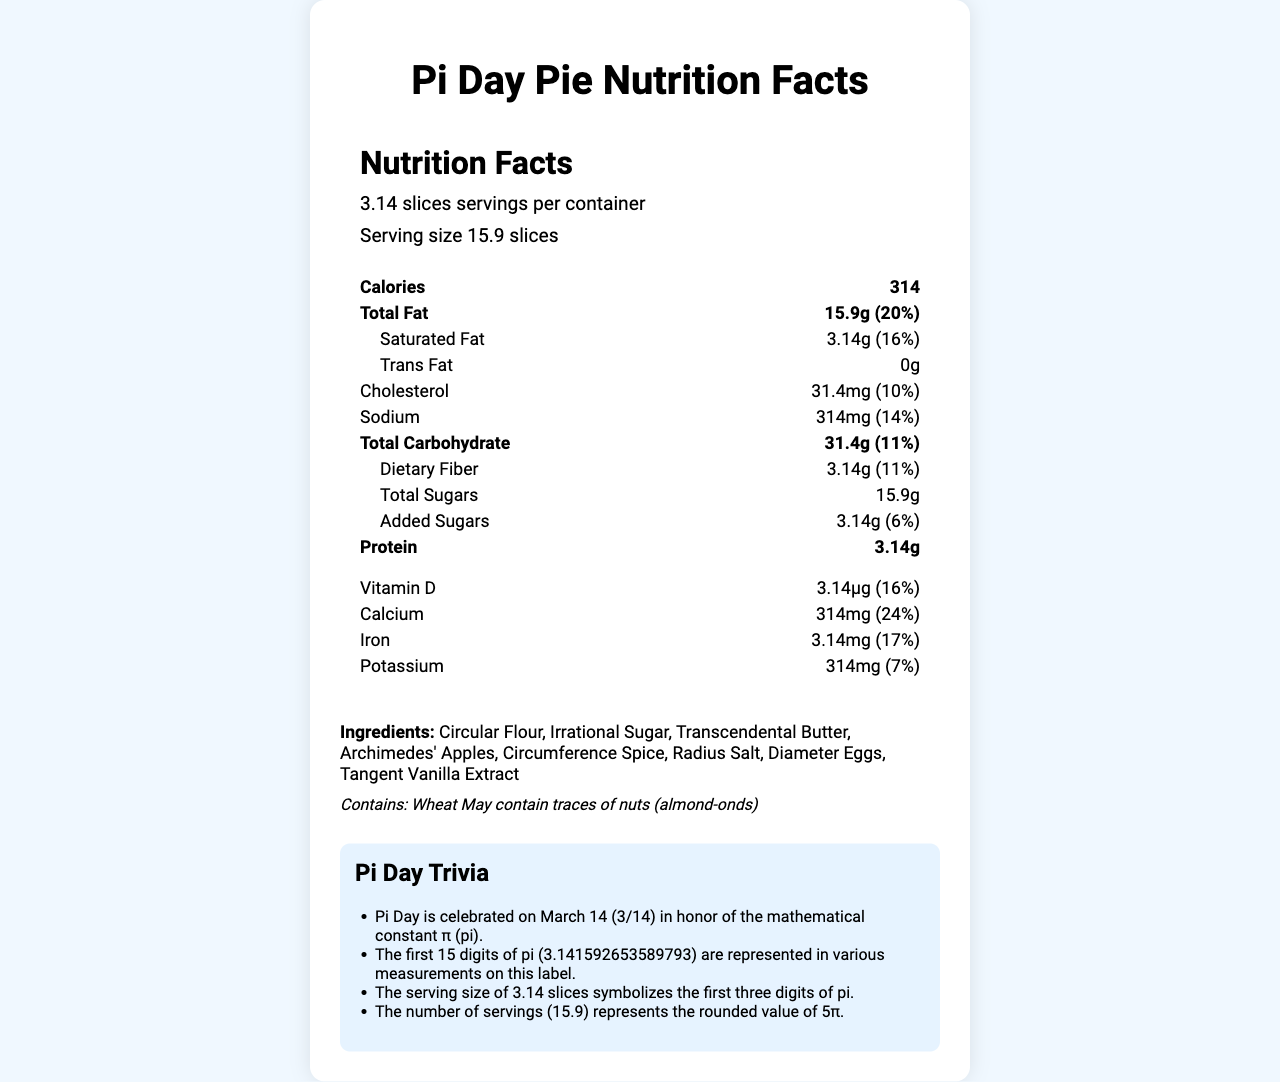what is the serving size for the Pi Day Pie? The serving size is clearly listed as "3.14 slices" in the document.
Answer: 3.14 slices how many calories are there per serving? The number of calories per serving is listed as "314" in the document.
Answer: 314 what percentage of the daily value is provided by the total fat in one serving? The daily value percentage for total fat is listed as "20%" for one serving.
Answer: 20% how much vitamin D is in a serving and what percentage of the daily value does this represent? There are 3.14 micrograms of vitamin D in a serving, which represents 16% of the daily value.
Answer: 3.14 micrograms, 16% what ingredients are present in the Pi Day Pie? The ingredients are listed under the ingredients section in the document.
Answer: Circular Flour, Irrational Sugar, Transcendental Butter, Archimedes' Apples, Circumference Spice, Radius Salt, Diameter Eggs, Tangent Vanilla Extract how much sodium is there per serving? Sodium content is listed as "314 milligrams" per serving.
Answer: 314 milligrams what is the significance of the serving size being 3.14 slices? A. It adheres to FDA guidelines B. It represents the first three digits of pi C. It is because the pie is very calorie-dense D. It was chosen randomly The serving size of 3.14 slices symbolizes the first three digits of pi as indicated in the trivia section.
Answer: B how many servings are there per container? A. 10 B. 12 C. 15.9 D. 20 The number of servings per container is listed as "15.9".
Answer: C is there any trans fat in the Pi Day Pie? The document lists the amount of trans fat as "0 grams".
Answer: No describe the main idea of the Pi Day Pie nutrition facts document. The document provides nutrition information for a pie themed around the mathematical constant pi, with serving sizes and nutritional values creatively aligning with pi’s digits. It includes calorie counts, fat content, vitamins, and minerals, along with ingredient and allergen info, and fun trivia about Pi.
Answer: The document displays the nutrition facts for a Pi Day-themed pie, where the measurements and percentages align with the digits of the mathematical constant pi (π). The serving size is 3.14 slices and contains 314 calories. The label includes detailed information on total fat, cholesterol, sodium, carbohydrates, dietary fiber, sugars, protein, vitamin D, calcium, iron, and potassium. Ingredients and allergens are listed, along with trivia about Pi and its representation in the label. how much potassium is in one serving and what percentage of the daily value does this represent? Potassium content is listed as "314 milligrams" per serving, corresponding to 7% of the daily value.
Answer: 314 milligrams, 7% what is the daily value percentage for added sugars? The daily value percentage for added sugars is listed as 6%.
Answer: 6% does the pie contain any wheat? The allergen section states that the pie contains wheat.
Answer: Yes what is the source of the trivia facts in the document? The source of the trivia facts is not mentioned in the document.
Answer: Not enough information why might the Pi Day Pie include 3.14 grams of saturated fat? The quantities and measurements in the Pi Day Pie nutrition facts, like 3.14 grams of saturated fat, are chosen to align with the digits of pi as a thematic choice.
Answer: To align with the digits of pi 